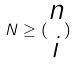<formula> <loc_0><loc_0><loc_500><loc_500>N \geq ( \begin{matrix} n \\ i \end{matrix} )</formula> 